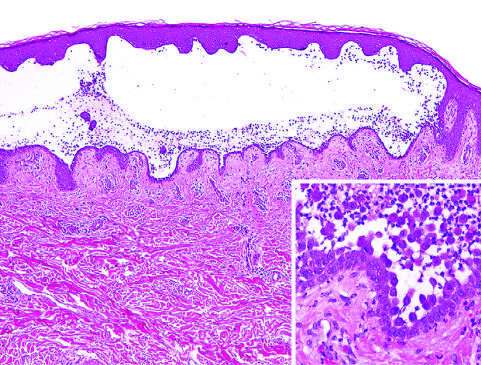re acute tubular epithelial cell injury with blebbing at the luminal pole plentiful?
Answer the question using a single word or phrase. No 